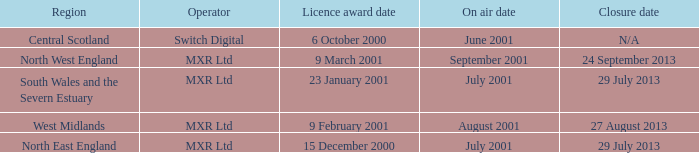What is the license award date for North East England? 15 December 2000. 